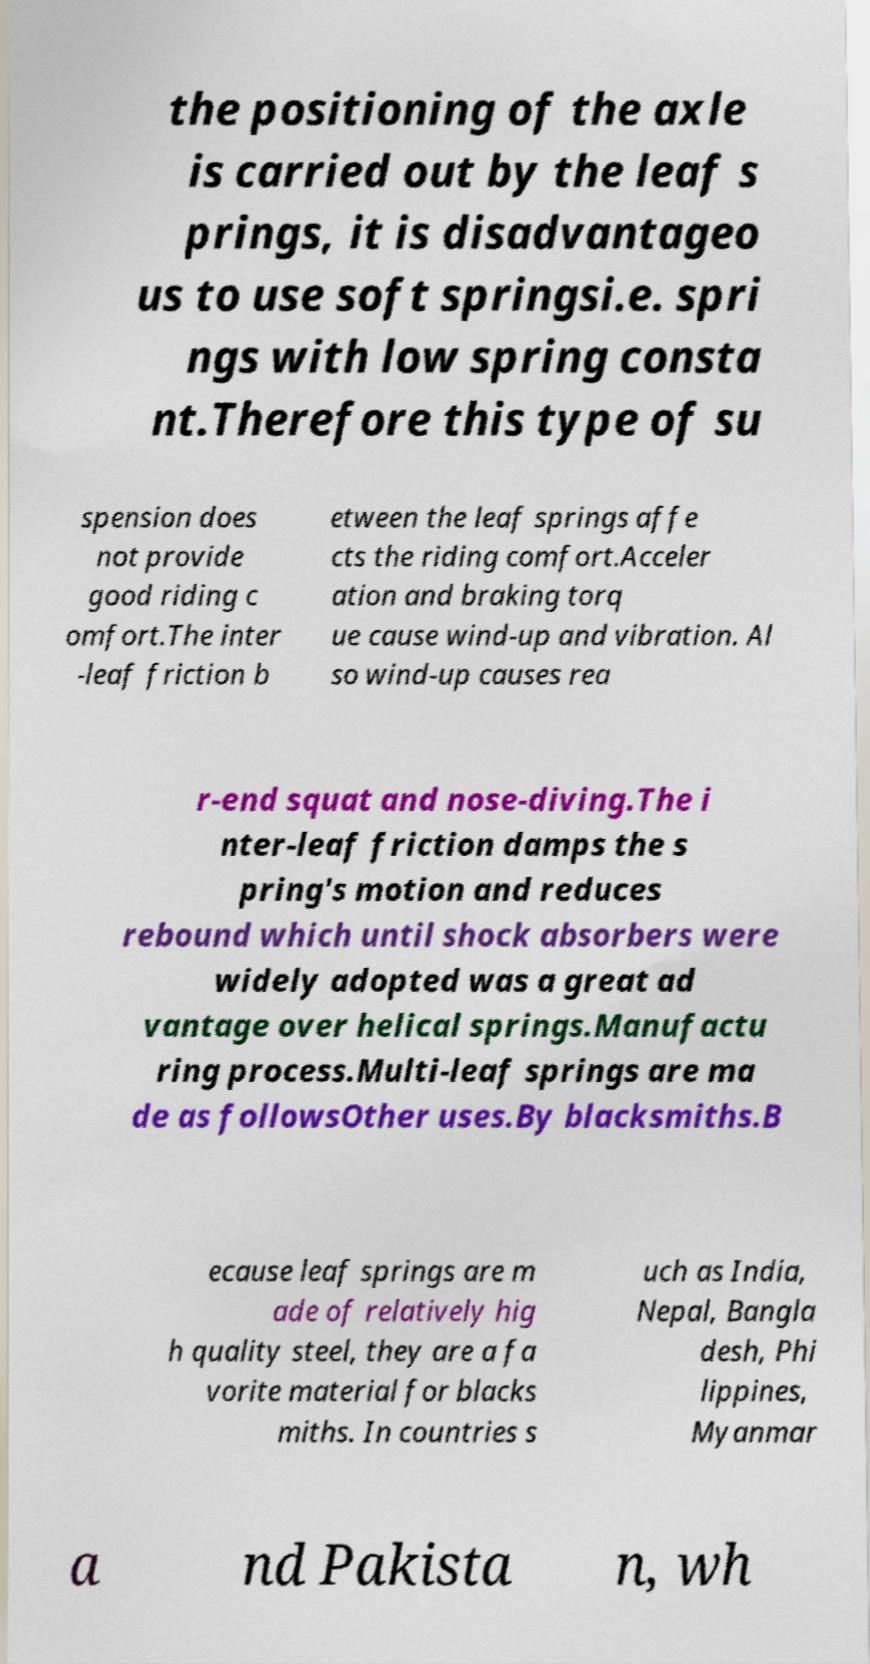Please read and relay the text visible in this image. What does it say? the positioning of the axle is carried out by the leaf s prings, it is disadvantageo us to use soft springsi.e. spri ngs with low spring consta nt.Therefore this type of su spension does not provide good riding c omfort.The inter -leaf friction b etween the leaf springs affe cts the riding comfort.Acceler ation and braking torq ue cause wind-up and vibration. Al so wind-up causes rea r-end squat and nose-diving.The i nter-leaf friction damps the s pring's motion and reduces rebound which until shock absorbers were widely adopted was a great ad vantage over helical springs.Manufactu ring process.Multi-leaf springs are ma de as followsOther uses.By blacksmiths.B ecause leaf springs are m ade of relatively hig h quality steel, they are a fa vorite material for blacks miths. In countries s uch as India, Nepal, Bangla desh, Phi lippines, Myanmar a nd Pakista n, wh 